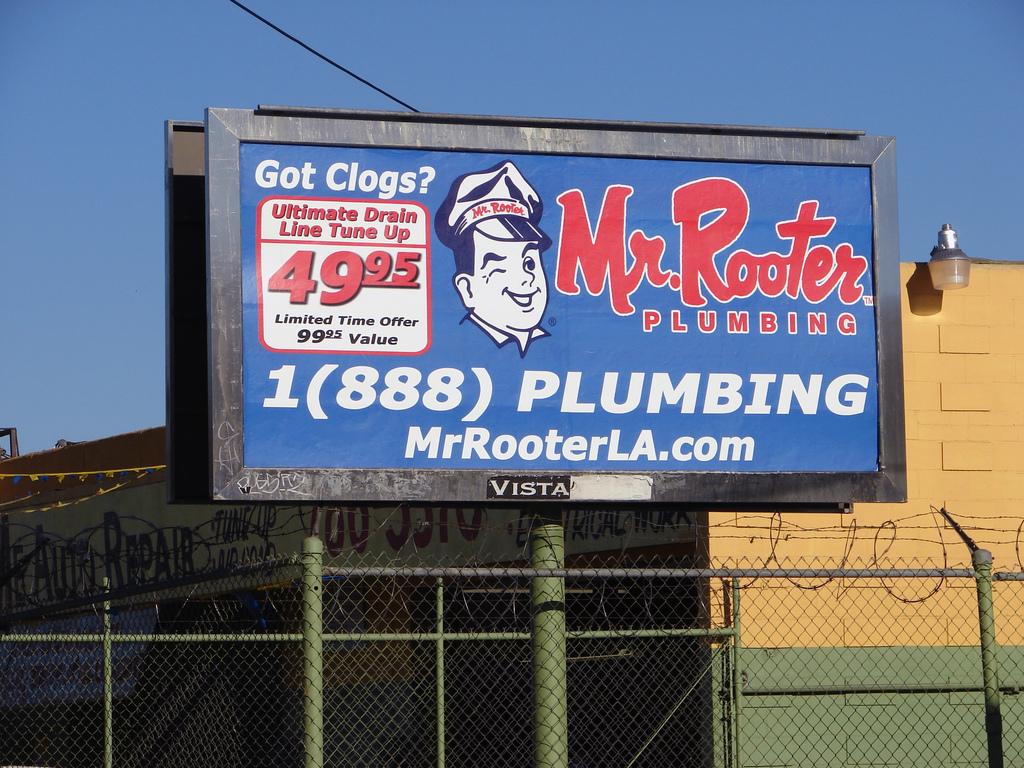What is the phone number on the billboard?
Provide a succinct answer. 1 888 plumbing. What is the company name?
Provide a succinct answer. Mr. rooter plumbing. 